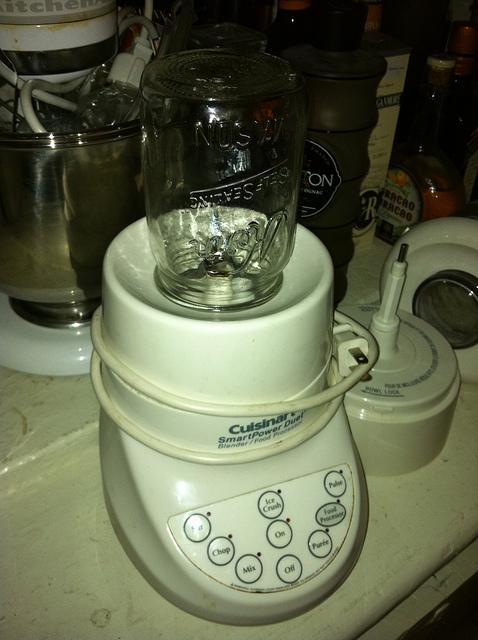What kind of jar is on top of the blender?
Concise answer only. Mason. What color is the countertop?
Answer briefly. White. Is this a blender?
Give a very brief answer. Yes. Is any food currently in the machine?
Short answer required. No. 